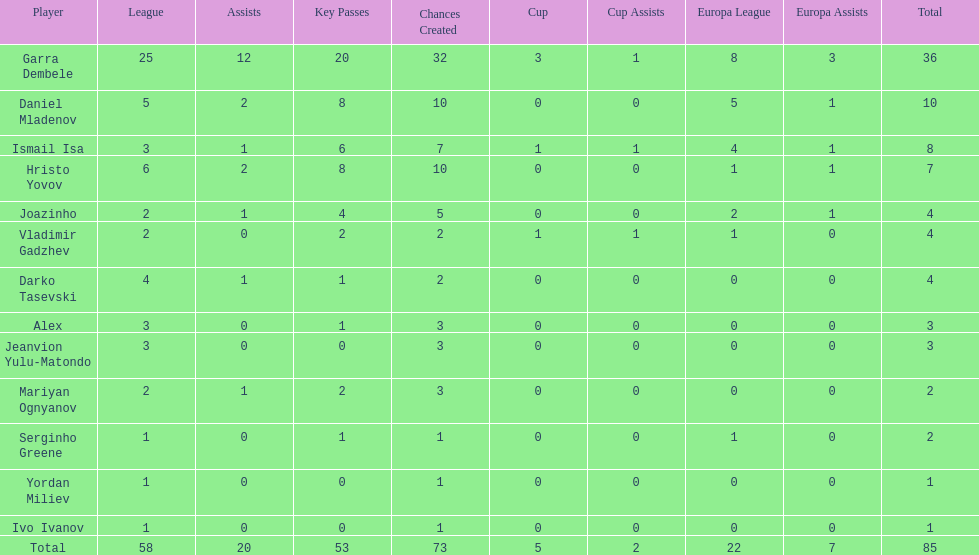What is the difference between vladimir gadzhev and yordan miliev's scores? 3. Give me the full table as a dictionary. {'header': ['Player', 'League', 'Assists', 'Key Passes', 'Chances Created', 'Cup', 'Cup Assists', 'Europa League', 'Europa Assists', 'Total'], 'rows': [['Garra Dembele', '25', '12', '20', '32', '3', '1', '8', '3', '36'], ['Daniel Mladenov', '5', '2', '8', '10', '0', '0', '5', '1', '10'], ['Ismail Isa', '3', '1', '6', '7', '1', '1', '4', '1', '8'], ['Hristo Yovov', '6', '2', '8', '10', '0', '0', '1', '1', '7'], ['Joazinho', '2', '1', '4', '5', '0', '0', '2', '1', '4'], ['Vladimir Gadzhev', '2', '0', '2', '2', '1', '1', '1', '0', '4'], ['Darko Tasevski', '4', '1', '1', '2', '0', '0', '0', '0', '4'], ['Alex', '3', '0', '1', '3', '0', '0', '0', '0', '3'], ['Jeanvion Yulu-Matondo', '3', '0', '0', '3', '0', '0', '0', '0', '3'], ['Mariyan Ognyanov', '2', '1', '2', '3', '0', '0', '0', '0', '2'], ['Serginho Greene', '1', '0', '1', '1', '0', '0', '1', '0', '2'], ['Yordan Miliev', '1', '0', '0', '1', '0', '0', '0', '0', '1'], ['Ivo Ivanov', '1', '0', '0', '1', '0', '0', '0', '0', '1'], ['Total', '58', '20', '53', '73', '5', '2', '22', '7', '85']]} 